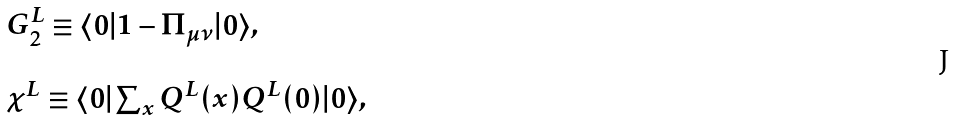<formula> <loc_0><loc_0><loc_500><loc_500>\begin{array} { l } G _ { 2 } ^ { L } \equiv \langle 0 | 1 - \Pi _ { \mu \nu } | 0 \rangle , \\ \\ \chi ^ { L } \equiv \langle 0 | \sum _ { x } Q ^ { L } ( x ) Q ^ { L } ( 0 ) | 0 \rangle , \end{array}</formula> 